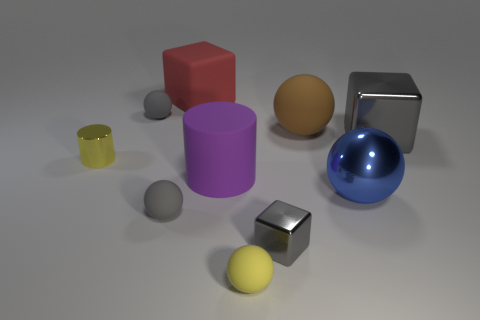Subtract all metallic balls. How many balls are left? 4 Subtract 3 spheres. How many spheres are left? 2 Subtract all yellow spheres. How many spheres are left? 4 Subtract all red balls. Subtract all gray cubes. How many balls are left? 5 Subtract all cylinders. How many objects are left? 8 Add 2 large gray metal blocks. How many large gray metal blocks are left? 3 Add 5 large yellow shiny things. How many large yellow shiny things exist? 5 Subtract 0 purple spheres. How many objects are left? 10 Subtract all small yellow balls. Subtract all purple things. How many objects are left? 8 